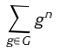<formula> <loc_0><loc_0><loc_500><loc_500>\sum _ { g \in G } g ^ { n }</formula> 